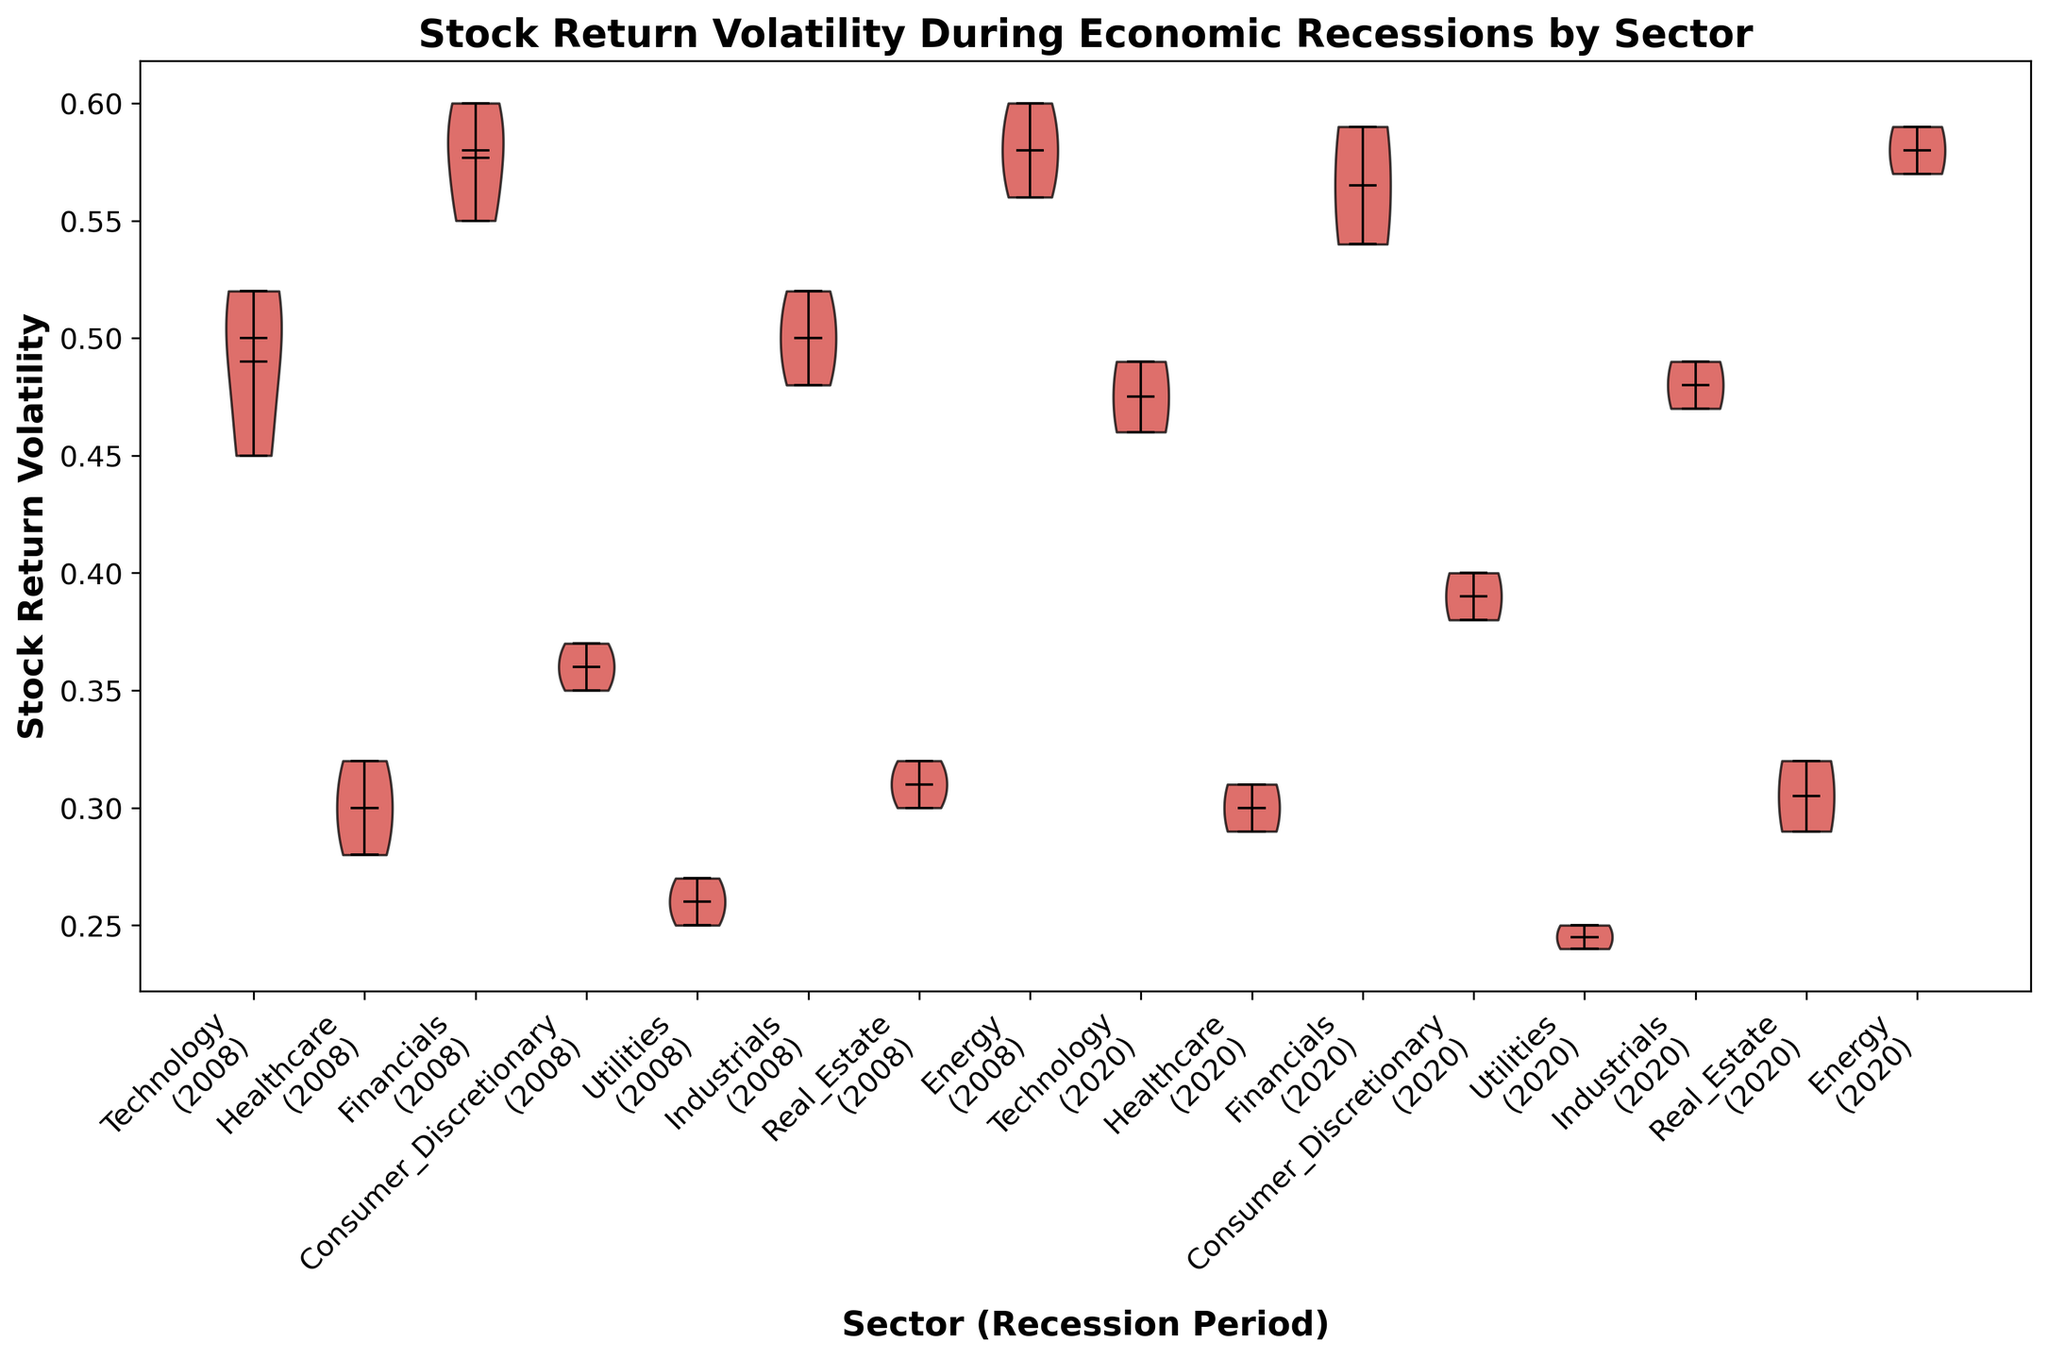Which sector exhibited the highest stock return volatility during the 2020 recession? To determine this, look at the violins for 2020 and find the one with the highest values among different sectors.
Answer: Financials What is the difference in median stock return volatility between the Technology sector in 2008 and 2020? Identify the medians for the Technology sector from both 2008 and 2020 (marked by a line within the violin plot) and calculate their difference.
Answer: 0.02 Which sector showed the least variation in stock return volatility during the 2008 recession? The sector with the smallest range of stock return volatility during 2008 can be seen by comparing the heights of the violin plots; the shorter the height, the smaller the variation.
Answer: Utilities How do the average stock return volatilities of the Energy sector across both recessions compare? Calculate the average values from the Energy sector for both 2008 and 2020 by adding the points within each period and dividing by the number of points, then compare them.
Answer: 0.58 in 2008, 0.58 in 2020 Which sector had an increase in median stock return volatility from the 2008 to 2020 recession? Check the median lines (usually thicker horizontal lines) of each sector for both years and identify which sector has a higher median in 2020 than in 2008.
Answer: Consumer Discretionary Is the range of stock return volatility in Healthcare in 2008 narrower or broader compared to 2020? Compare the range (difference between the highest and lowest points) of the violin plots for Healthcare in both years.
Answer: Narrower in 2020 What is the median stock return volatility for the Utilities sector in 2020? Identify the median of the Utilities sector for 2020, indicated by the thicker horizontal line in the 2020 portion of the plot.
Answer: 0.25 Compare the mean stock return volatilities of the Industrials sector in 2008 to the Technology sector in 2008. Using the mean values usually marked within the violin plot, compare the ones from Industrials and Technology for the year 2008.
Answer: Industrials: 0.50, Technology: 0.49 